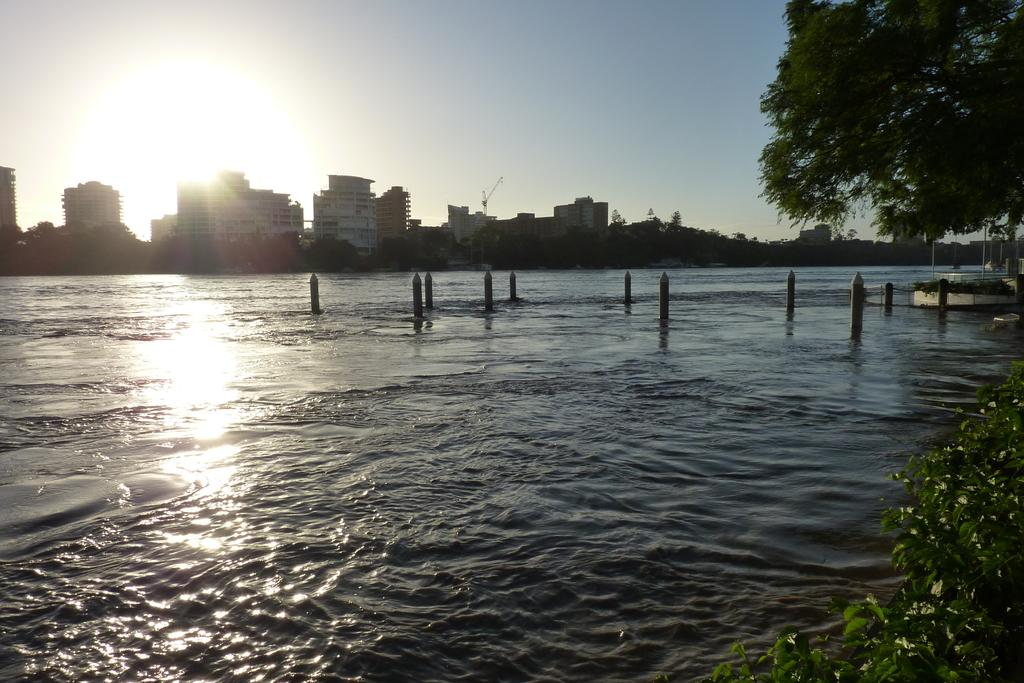What is visible in the image? Water, poles, leaves, buildings, trees, and the sky are visible in the image. Where are the leaves located in the image? The leaves are present on the right side of the image. What can be seen in the background of the image? Buildings, trees, and the sky are visible in the background of the image. Can you see a ball being thrown through the window in the image? There is no ball or window present in the image. Is there a drain visible in the image? There is no drain visible in the image. 